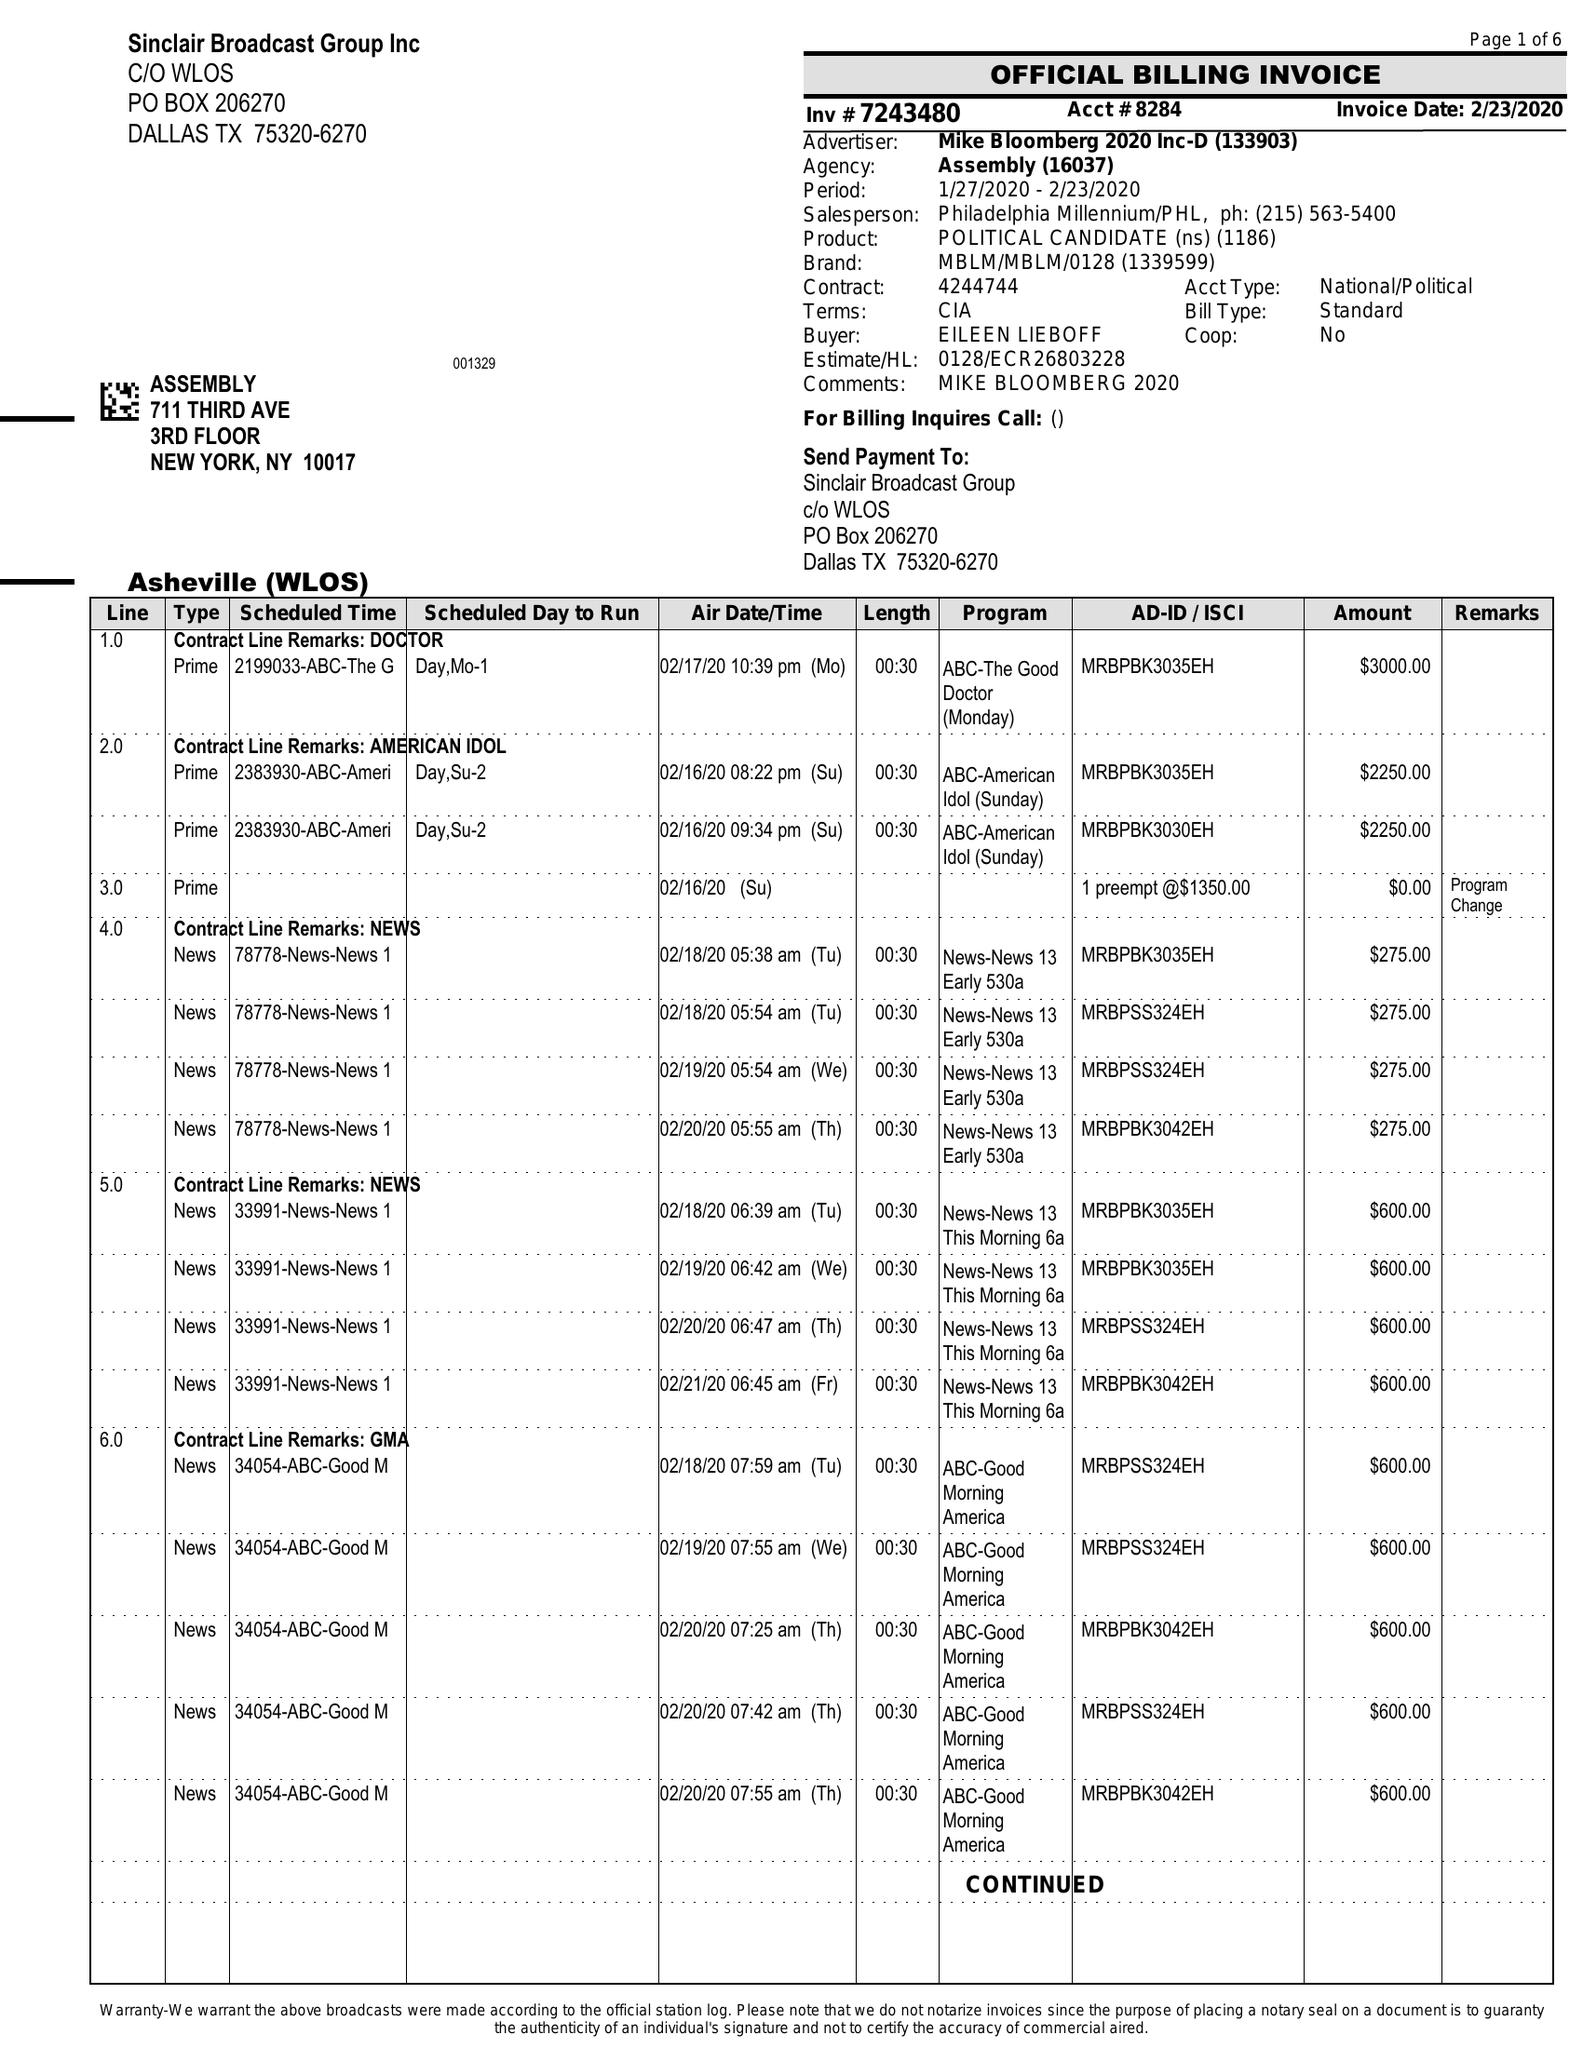What is the value for the contract_num?
Answer the question using a single word or phrase. 7243480 